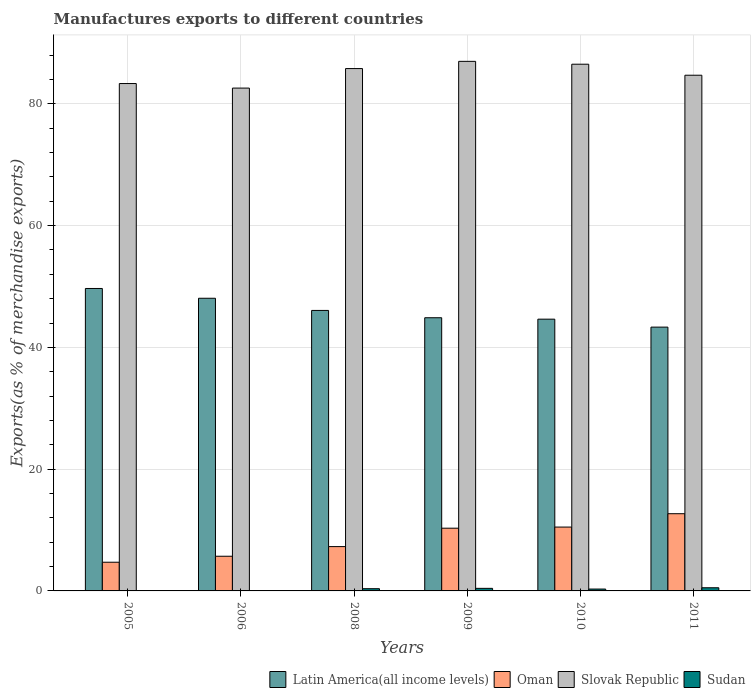How many bars are there on the 1st tick from the right?
Your answer should be compact. 4. What is the label of the 6th group of bars from the left?
Make the answer very short. 2011. In how many cases, is the number of bars for a given year not equal to the number of legend labels?
Keep it short and to the point. 0. What is the percentage of exports to different countries in Latin America(all income levels) in 2005?
Provide a succinct answer. 49.68. Across all years, what is the maximum percentage of exports to different countries in Latin America(all income levels)?
Provide a succinct answer. 49.68. Across all years, what is the minimum percentage of exports to different countries in Slovak Republic?
Provide a short and direct response. 82.59. In which year was the percentage of exports to different countries in Sudan minimum?
Offer a very short reply. 2006. What is the total percentage of exports to different countries in Oman in the graph?
Make the answer very short. 51.16. What is the difference between the percentage of exports to different countries in Oman in 2005 and that in 2008?
Your answer should be compact. -2.57. What is the difference between the percentage of exports to different countries in Latin America(all income levels) in 2005 and the percentage of exports to different countries in Slovak Republic in 2006?
Ensure brevity in your answer.  -32.92. What is the average percentage of exports to different countries in Sudan per year?
Give a very brief answer. 0.28. In the year 2011, what is the difference between the percentage of exports to different countries in Latin America(all income levels) and percentage of exports to different countries in Oman?
Provide a succinct answer. 30.65. What is the ratio of the percentage of exports to different countries in Slovak Republic in 2010 to that in 2011?
Provide a short and direct response. 1.02. Is the percentage of exports to different countries in Sudan in 2005 less than that in 2010?
Ensure brevity in your answer.  Yes. Is the difference between the percentage of exports to different countries in Latin America(all income levels) in 2008 and 2009 greater than the difference between the percentage of exports to different countries in Oman in 2008 and 2009?
Your answer should be very brief. Yes. What is the difference between the highest and the second highest percentage of exports to different countries in Latin America(all income levels)?
Offer a terse response. 1.6. What is the difference between the highest and the lowest percentage of exports to different countries in Latin America(all income levels)?
Provide a succinct answer. 6.35. In how many years, is the percentage of exports to different countries in Oman greater than the average percentage of exports to different countries in Oman taken over all years?
Your response must be concise. 3. What does the 4th bar from the left in 2011 represents?
Give a very brief answer. Sudan. What does the 4th bar from the right in 2009 represents?
Ensure brevity in your answer.  Latin America(all income levels). Is it the case that in every year, the sum of the percentage of exports to different countries in Oman and percentage of exports to different countries in Latin America(all income levels) is greater than the percentage of exports to different countries in Slovak Republic?
Give a very brief answer. No. How many bars are there?
Your response must be concise. 24. Are all the bars in the graph horizontal?
Provide a succinct answer. No. How many years are there in the graph?
Provide a short and direct response. 6. What is the difference between two consecutive major ticks on the Y-axis?
Your answer should be compact. 20. Does the graph contain grids?
Make the answer very short. Yes. Where does the legend appear in the graph?
Offer a terse response. Bottom right. How many legend labels are there?
Ensure brevity in your answer.  4. What is the title of the graph?
Offer a very short reply. Manufactures exports to different countries. What is the label or title of the Y-axis?
Offer a very short reply. Exports(as % of merchandise exports). What is the Exports(as % of merchandise exports) of Latin America(all income levels) in 2005?
Provide a succinct answer. 49.68. What is the Exports(as % of merchandise exports) in Oman in 2005?
Provide a succinct answer. 4.71. What is the Exports(as % of merchandise exports) in Slovak Republic in 2005?
Your answer should be compact. 83.34. What is the Exports(as % of merchandise exports) of Sudan in 2005?
Provide a short and direct response. 0.06. What is the Exports(as % of merchandise exports) in Latin America(all income levels) in 2006?
Keep it short and to the point. 48.07. What is the Exports(as % of merchandise exports) in Oman in 2006?
Provide a succinct answer. 5.7. What is the Exports(as % of merchandise exports) in Slovak Republic in 2006?
Your answer should be compact. 82.59. What is the Exports(as % of merchandise exports) of Sudan in 2006?
Provide a succinct answer. 0.03. What is the Exports(as % of merchandise exports) in Latin America(all income levels) in 2008?
Provide a succinct answer. 46.07. What is the Exports(as % of merchandise exports) in Oman in 2008?
Provide a short and direct response. 7.28. What is the Exports(as % of merchandise exports) of Slovak Republic in 2008?
Ensure brevity in your answer.  85.79. What is the Exports(as % of merchandise exports) of Sudan in 2008?
Offer a terse response. 0.36. What is the Exports(as % of merchandise exports) of Latin America(all income levels) in 2009?
Your answer should be very brief. 44.87. What is the Exports(as % of merchandise exports) of Oman in 2009?
Your answer should be compact. 10.3. What is the Exports(as % of merchandise exports) in Slovak Republic in 2009?
Your answer should be very brief. 86.98. What is the Exports(as % of merchandise exports) of Sudan in 2009?
Your answer should be very brief. 0.42. What is the Exports(as % of merchandise exports) of Latin America(all income levels) in 2010?
Make the answer very short. 44.64. What is the Exports(as % of merchandise exports) of Oman in 2010?
Keep it short and to the point. 10.49. What is the Exports(as % of merchandise exports) in Slovak Republic in 2010?
Offer a very short reply. 86.51. What is the Exports(as % of merchandise exports) in Sudan in 2010?
Provide a short and direct response. 0.31. What is the Exports(as % of merchandise exports) of Latin America(all income levels) in 2011?
Make the answer very short. 43.33. What is the Exports(as % of merchandise exports) in Oman in 2011?
Offer a very short reply. 12.68. What is the Exports(as % of merchandise exports) of Slovak Republic in 2011?
Ensure brevity in your answer.  84.7. What is the Exports(as % of merchandise exports) of Sudan in 2011?
Provide a short and direct response. 0.52. Across all years, what is the maximum Exports(as % of merchandise exports) in Latin America(all income levels)?
Offer a terse response. 49.68. Across all years, what is the maximum Exports(as % of merchandise exports) in Oman?
Make the answer very short. 12.68. Across all years, what is the maximum Exports(as % of merchandise exports) of Slovak Republic?
Offer a terse response. 86.98. Across all years, what is the maximum Exports(as % of merchandise exports) of Sudan?
Your answer should be compact. 0.52. Across all years, what is the minimum Exports(as % of merchandise exports) of Latin America(all income levels)?
Provide a short and direct response. 43.33. Across all years, what is the minimum Exports(as % of merchandise exports) of Oman?
Give a very brief answer. 4.71. Across all years, what is the minimum Exports(as % of merchandise exports) of Slovak Republic?
Offer a terse response. 82.59. Across all years, what is the minimum Exports(as % of merchandise exports) in Sudan?
Make the answer very short. 0.03. What is the total Exports(as % of merchandise exports) in Latin America(all income levels) in the graph?
Make the answer very short. 276.65. What is the total Exports(as % of merchandise exports) of Oman in the graph?
Provide a short and direct response. 51.16. What is the total Exports(as % of merchandise exports) of Slovak Republic in the graph?
Your answer should be compact. 509.92. What is the total Exports(as % of merchandise exports) of Sudan in the graph?
Keep it short and to the point. 1.7. What is the difference between the Exports(as % of merchandise exports) of Latin America(all income levels) in 2005 and that in 2006?
Keep it short and to the point. 1.6. What is the difference between the Exports(as % of merchandise exports) in Oman in 2005 and that in 2006?
Provide a succinct answer. -0.98. What is the difference between the Exports(as % of merchandise exports) of Slovak Republic in 2005 and that in 2006?
Ensure brevity in your answer.  0.75. What is the difference between the Exports(as % of merchandise exports) of Sudan in 2005 and that in 2006?
Your answer should be very brief. 0.03. What is the difference between the Exports(as % of merchandise exports) in Latin America(all income levels) in 2005 and that in 2008?
Your answer should be very brief. 3.6. What is the difference between the Exports(as % of merchandise exports) of Oman in 2005 and that in 2008?
Make the answer very short. -2.57. What is the difference between the Exports(as % of merchandise exports) in Slovak Republic in 2005 and that in 2008?
Provide a succinct answer. -2.46. What is the difference between the Exports(as % of merchandise exports) of Sudan in 2005 and that in 2008?
Provide a short and direct response. -0.31. What is the difference between the Exports(as % of merchandise exports) in Latin America(all income levels) in 2005 and that in 2009?
Make the answer very short. 4.8. What is the difference between the Exports(as % of merchandise exports) in Oman in 2005 and that in 2009?
Your answer should be compact. -5.59. What is the difference between the Exports(as % of merchandise exports) of Slovak Republic in 2005 and that in 2009?
Give a very brief answer. -3.64. What is the difference between the Exports(as % of merchandise exports) of Sudan in 2005 and that in 2009?
Your answer should be very brief. -0.36. What is the difference between the Exports(as % of merchandise exports) in Latin America(all income levels) in 2005 and that in 2010?
Give a very brief answer. 5.04. What is the difference between the Exports(as % of merchandise exports) of Oman in 2005 and that in 2010?
Offer a very short reply. -5.77. What is the difference between the Exports(as % of merchandise exports) in Slovak Republic in 2005 and that in 2010?
Your answer should be compact. -3.17. What is the difference between the Exports(as % of merchandise exports) in Sudan in 2005 and that in 2010?
Offer a very short reply. -0.25. What is the difference between the Exports(as % of merchandise exports) in Latin America(all income levels) in 2005 and that in 2011?
Ensure brevity in your answer.  6.35. What is the difference between the Exports(as % of merchandise exports) in Oman in 2005 and that in 2011?
Your answer should be compact. -7.97. What is the difference between the Exports(as % of merchandise exports) of Slovak Republic in 2005 and that in 2011?
Your answer should be very brief. -1.37. What is the difference between the Exports(as % of merchandise exports) of Sudan in 2005 and that in 2011?
Offer a terse response. -0.46. What is the difference between the Exports(as % of merchandise exports) in Latin America(all income levels) in 2006 and that in 2008?
Your response must be concise. 2. What is the difference between the Exports(as % of merchandise exports) of Oman in 2006 and that in 2008?
Provide a short and direct response. -1.58. What is the difference between the Exports(as % of merchandise exports) of Slovak Republic in 2006 and that in 2008?
Ensure brevity in your answer.  -3.2. What is the difference between the Exports(as % of merchandise exports) in Sudan in 2006 and that in 2008?
Your answer should be very brief. -0.34. What is the difference between the Exports(as % of merchandise exports) of Latin America(all income levels) in 2006 and that in 2009?
Offer a very short reply. 3.2. What is the difference between the Exports(as % of merchandise exports) in Oman in 2006 and that in 2009?
Offer a very short reply. -4.61. What is the difference between the Exports(as % of merchandise exports) of Slovak Republic in 2006 and that in 2009?
Provide a succinct answer. -4.39. What is the difference between the Exports(as % of merchandise exports) of Sudan in 2006 and that in 2009?
Your response must be concise. -0.39. What is the difference between the Exports(as % of merchandise exports) of Latin America(all income levels) in 2006 and that in 2010?
Your answer should be compact. 3.44. What is the difference between the Exports(as % of merchandise exports) of Oman in 2006 and that in 2010?
Offer a very short reply. -4.79. What is the difference between the Exports(as % of merchandise exports) of Slovak Republic in 2006 and that in 2010?
Offer a very short reply. -3.92. What is the difference between the Exports(as % of merchandise exports) of Sudan in 2006 and that in 2010?
Provide a succinct answer. -0.28. What is the difference between the Exports(as % of merchandise exports) of Latin America(all income levels) in 2006 and that in 2011?
Ensure brevity in your answer.  4.74. What is the difference between the Exports(as % of merchandise exports) of Oman in 2006 and that in 2011?
Your response must be concise. -6.98. What is the difference between the Exports(as % of merchandise exports) in Slovak Republic in 2006 and that in 2011?
Offer a terse response. -2.11. What is the difference between the Exports(as % of merchandise exports) in Sudan in 2006 and that in 2011?
Offer a very short reply. -0.49. What is the difference between the Exports(as % of merchandise exports) of Latin America(all income levels) in 2008 and that in 2009?
Ensure brevity in your answer.  1.2. What is the difference between the Exports(as % of merchandise exports) of Oman in 2008 and that in 2009?
Provide a succinct answer. -3.02. What is the difference between the Exports(as % of merchandise exports) of Slovak Republic in 2008 and that in 2009?
Your answer should be compact. -1.19. What is the difference between the Exports(as % of merchandise exports) in Sudan in 2008 and that in 2009?
Your response must be concise. -0.06. What is the difference between the Exports(as % of merchandise exports) of Latin America(all income levels) in 2008 and that in 2010?
Give a very brief answer. 1.44. What is the difference between the Exports(as % of merchandise exports) in Oman in 2008 and that in 2010?
Provide a short and direct response. -3.21. What is the difference between the Exports(as % of merchandise exports) of Slovak Republic in 2008 and that in 2010?
Offer a terse response. -0.72. What is the difference between the Exports(as % of merchandise exports) of Sudan in 2008 and that in 2010?
Ensure brevity in your answer.  0.06. What is the difference between the Exports(as % of merchandise exports) of Latin America(all income levels) in 2008 and that in 2011?
Make the answer very short. 2.74. What is the difference between the Exports(as % of merchandise exports) in Oman in 2008 and that in 2011?
Your answer should be compact. -5.4. What is the difference between the Exports(as % of merchandise exports) of Slovak Republic in 2008 and that in 2011?
Make the answer very short. 1.09. What is the difference between the Exports(as % of merchandise exports) in Sudan in 2008 and that in 2011?
Provide a short and direct response. -0.15. What is the difference between the Exports(as % of merchandise exports) of Latin America(all income levels) in 2009 and that in 2010?
Offer a very short reply. 0.23. What is the difference between the Exports(as % of merchandise exports) in Oman in 2009 and that in 2010?
Make the answer very short. -0.18. What is the difference between the Exports(as % of merchandise exports) in Slovak Republic in 2009 and that in 2010?
Provide a short and direct response. 0.47. What is the difference between the Exports(as % of merchandise exports) of Sudan in 2009 and that in 2010?
Give a very brief answer. 0.11. What is the difference between the Exports(as % of merchandise exports) in Latin America(all income levels) in 2009 and that in 2011?
Give a very brief answer. 1.54. What is the difference between the Exports(as % of merchandise exports) of Oman in 2009 and that in 2011?
Provide a succinct answer. -2.38. What is the difference between the Exports(as % of merchandise exports) in Slovak Republic in 2009 and that in 2011?
Keep it short and to the point. 2.28. What is the difference between the Exports(as % of merchandise exports) in Sudan in 2009 and that in 2011?
Provide a succinct answer. -0.1. What is the difference between the Exports(as % of merchandise exports) in Latin America(all income levels) in 2010 and that in 2011?
Your response must be concise. 1.31. What is the difference between the Exports(as % of merchandise exports) of Oman in 2010 and that in 2011?
Offer a very short reply. -2.19. What is the difference between the Exports(as % of merchandise exports) in Slovak Republic in 2010 and that in 2011?
Provide a succinct answer. 1.81. What is the difference between the Exports(as % of merchandise exports) in Sudan in 2010 and that in 2011?
Make the answer very short. -0.21. What is the difference between the Exports(as % of merchandise exports) in Latin America(all income levels) in 2005 and the Exports(as % of merchandise exports) in Oman in 2006?
Provide a succinct answer. 43.98. What is the difference between the Exports(as % of merchandise exports) in Latin America(all income levels) in 2005 and the Exports(as % of merchandise exports) in Slovak Republic in 2006?
Your response must be concise. -32.92. What is the difference between the Exports(as % of merchandise exports) in Latin America(all income levels) in 2005 and the Exports(as % of merchandise exports) in Sudan in 2006?
Make the answer very short. 49.65. What is the difference between the Exports(as % of merchandise exports) in Oman in 2005 and the Exports(as % of merchandise exports) in Slovak Republic in 2006?
Your answer should be compact. -77.88. What is the difference between the Exports(as % of merchandise exports) of Oman in 2005 and the Exports(as % of merchandise exports) of Sudan in 2006?
Your answer should be compact. 4.69. What is the difference between the Exports(as % of merchandise exports) of Slovak Republic in 2005 and the Exports(as % of merchandise exports) of Sudan in 2006?
Make the answer very short. 83.31. What is the difference between the Exports(as % of merchandise exports) of Latin America(all income levels) in 2005 and the Exports(as % of merchandise exports) of Oman in 2008?
Your answer should be very brief. 42.4. What is the difference between the Exports(as % of merchandise exports) of Latin America(all income levels) in 2005 and the Exports(as % of merchandise exports) of Slovak Republic in 2008?
Your answer should be compact. -36.12. What is the difference between the Exports(as % of merchandise exports) in Latin America(all income levels) in 2005 and the Exports(as % of merchandise exports) in Sudan in 2008?
Give a very brief answer. 49.31. What is the difference between the Exports(as % of merchandise exports) in Oman in 2005 and the Exports(as % of merchandise exports) in Slovak Republic in 2008?
Provide a short and direct response. -81.08. What is the difference between the Exports(as % of merchandise exports) of Oman in 2005 and the Exports(as % of merchandise exports) of Sudan in 2008?
Offer a terse response. 4.35. What is the difference between the Exports(as % of merchandise exports) in Slovak Republic in 2005 and the Exports(as % of merchandise exports) in Sudan in 2008?
Your answer should be compact. 82.97. What is the difference between the Exports(as % of merchandise exports) of Latin America(all income levels) in 2005 and the Exports(as % of merchandise exports) of Oman in 2009?
Provide a succinct answer. 39.37. What is the difference between the Exports(as % of merchandise exports) in Latin America(all income levels) in 2005 and the Exports(as % of merchandise exports) in Slovak Republic in 2009?
Offer a terse response. -37.31. What is the difference between the Exports(as % of merchandise exports) of Latin America(all income levels) in 2005 and the Exports(as % of merchandise exports) of Sudan in 2009?
Provide a succinct answer. 49.25. What is the difference between the Exports(as % of merchandise exports) in Oman in 2005 and the Exports(as % of merchandise exports) in Slovak Republic in 2009?
Provide a short and direct response. -82.27. What is the difference between the Exports(as % of merchandise exports) in Oman in 2005 and the Exports(as % of merchandise exports) in Sudan in 2009?
Offer a very short reply. 4.29. What is the difference between the Exports(as % of merchandise exports) of Slovak Republic in 2005 and the Exports(as % of merchandise exports) of Sudan in 2009?
Make the answer very short. 82.91. What is the difference between the Exports(as % of merchandise exports) of Latin America(all income levels) in 2005 and the Exports(as % of merchandise exports) of Oman in 2010?
Ensure brevity in your answer.  39.19. What is the difference between the Exports(as % of merchandise exports) of Latin America(all income levels) in 2005 and the Exports(as % of merchandise exports) of Slovak Republic in 2010?
Ensure brevity in your answer.  -36.84. What is the difference between the Exports(as % of merchandise exports) of Latin America(all income levels) in 2005 and the Exports(as % of merchandise exports) of Sudan in 2010?
Give a very brief answer. 49.37. What is the difference between the Exports(as % of merchandise exports) of Oman in 2005 and the Exports(as % of merchandise exports) of Slovak Republic in 2010?
Provide a short and direct response. -81.8. What is the difference between the Exports(as % of merchandise exports) in Oman in 2005 and the Exports(as % of merchandise exports) in Sudan in 2010?
Offer a very short reply. 4.41. What is the difference between the Exports(as % of merchandise exports) of Slovak Republic in 2005 and the Exports(as % of merchandise exports) of Sudan in 2010?
Provide a succinct answer. 83.03. What is the difference between the Exports(as % of merchandise exports) in Latin America(all income levels) in 2005 and the Exports(as % of merchandise exports) in Oman in 2011?
Your answer should be very brief. 36.99. What is the difference between the Exports(as % of merchandise exports) of Latin America(all income levels) in 2005 and the Exports(as % of merchandise exports) of Slovak Republic in 2011?
Give a very brief answer. -35.03. What is the difference between the Exports(as % of merchandise exports) in Latin America(all income levels) in 2005 and the Exports(as % of merchandise exports) in Sudan in 2011?
Ensure brevity in your answer.  49.16. What is the difference between the Exports(as % of merchandise exports) in Oman in 2005 and the Exports(as % of merchandise exports) in Slovak Republic in 2011?
Provide a succinct answer. -79.99. What is the difference between the Exports(as % of merchandise exports) in Oman in 2005 and the Exports(as % of merchandise exports) in Sudan in 2011?
Give a very brief answer. 4.19. What is the difference between the Exports(as % of merchandise exports) in Slovak Republic in 2005 and the Exports(as % of merchandise exports) in Sudan in 2011?
Ensure brevity in your answer.  82.82. What is the difference between the Exports(as % of merchandise exports) of Latin America(all income levels) in 2006 and the Exports(as % of merchandise exports) of Oman in 2008?
Offer a terse response. 40.79. What is the difference between the Exports(as % of merchandise exports) of Latin America(all income levels) in 2006 and the Exports(as % of merchandise exports) of Slovak Republic in 2008?
Ensure brevity in your answer.  -37.72. What is the difference between the Exports(as % of merchandise exports) in Latin America(all income levels) in 2006 and the Exports(as % of merchandise exports) in Sudan in 2008?
Provide a short and direct response. 47.71. What is the difference between the Exports(as % of merchandise exports) in Oman in 2006 and the Exports(as % of merchandise exports) in Slovak Republic in 2008?
Offer a terse response. -80.1. What is the difference between the Exports(as % of merchandise exports) in Oman in 2006 and the Exports(as % of merchandise exports) in Sudan in 2008?
Offer a terse response. 5.33. What is the difference between the Exports(as % of merchandise exports) in Slovak Republic in 2006 and the Exports(as % of merchandise exports) in Sudan in 2008?
Ensure brevity in your answer.  82.23. What is the difference between the Exports(as % of merchandise exports) in Latin America(all income levels) in 2006 and the Exports(as % of merchandise exports) in Oman in 2009?
Make the answer very short. 37.77. What is the difference between the Exports(as % of merchandise exports) in Latin America(all income levels) in 2006 and the Exports(as % of merchandise exports) in Slovak Republic in 2009?
Provide a short and direct response. -38.91. What is the difference between the Exports(as % of merchandise exports) in Latin America(all income levels) in 2006 and the Exports(as % of merchandise exports) in Sudan in 2009?
Keep it short and to the point. 47.65. What is the difference between the Exports(as % of merchandise exports) in Oman in 2006 and the Exports(as % of merchandise exports) in Slovak Republic in 2009?
Your response must be concise. -81.28. What is the difference between the Exports(as % of merchandise exports) of Oman in 2006 and the Exports(as % of merchandise exports) of Sudan in 2009?
Provide a succinct answer. 5.27. What is the difference between the Exports(as % of merchandise exports) in Slovak Republic in 2006 and the Exports(as % of merchandise exports) in Sudan in 2009?
Keep it short and to the point. 82.17. What is the difference between the Exports(as % of merchandise exports) in Latin America(all income levels) in 2006 and the Exports(as % of merchandise exports) in Oman in 2010?
Offer a very short reply. 37.58. What is the difference between the Exports(as % of merchandise exports) of Latin America(all income levels) in 2006 and the Exports(as % of merchandise exports) of Slovak Republic in 2010?
Keep it short and to the point. -38.44. What is the difference between the Exports(as % of merchandise exports) of Latin America(all income levels) in 2006 and the Exports(as % of merchandise exports) of Sudan in 2010?
Offer a very short reply. 47.76. What is the difference between the Exports(as % of merchandise exports) of Oman in 2006 and the Exports(as % of merchandise exports) of Slovak Republic in 2010?
Offer a terse response. -80.81. What is the difference between the Exports(as % of merchandise exports) in Oman in 2006 and the Exports(as % of merchandise exports) in Sudan in 2010?
Ensure brevity in your answer.  5.39. What is the difference between the Exports(as % of merchandise exports) of Slovak Republic in 2006 and the Exports(as % of merchandise exports) of Sudan in 2010?
Your answer should be very brief. 82.28. What is the difference between the Exports(as % of merchandise exports) in Latin America(all income levels) in 2006 and the Exports(as % of merchandise exports) in Oman in 2011?
Your answer should be very brief. 35.39. What is the difference between the Exports(as % of merchandise exports) of Latin America(all income levels) in 2006 and the Exports(as % of merchandise exports) of Slovak Republic in 2011?
Ensure brevity in your answer.  -36.63. What is the difference between the Exports(as % of merchandise exports) in Latin America(all income levels) in 2006 and the Exports(as % of merchandise exports) in Sudan in 2011?
Make the answer very short. 47.55. What is the difference between the Exports(as % of merchandise exports) in Oman in 2006 and the Exports(as % of merchandise exports) in Slovak Republic in 2011?
Offer a very short reply. -79.01. What is the difference between the Exports(as % of merchandise exports) in Oman in 2006 and the Exports(as % of merchandise exports) in Sudan in 2011?
Provide a succinct answer. 5.18. What is the difference between the Exports(as % of merchandise exports) in Slovak Republic in 2006 and the Exports(as % of merchandise exports) in Sudan in 2011?
Provide a succinct answer. 82.07. What is the difference between the Exports(as % of merchandise exports) of Latin America(all income levels) in 2008 and the Exports(as % of merchandise exports) of Oman in 2009?
Provide a short and direct response. 35.77. What is the difference between the Exports(as % of merchandise exports) in Latin America(all income levels) in 2008 and the Exports(as % of merchandise exports) in Slovak Republic in 2009?
Your response must be concise. -40.91. What is the difference between the Exports(as % of merchandise exports) of Latin America(all income levels) in 2008 and the Exports(as % of merchandise exports) of Sudan in 2009?
Provide a short and direct response. 45.65. What is the difference between the Exports(as % of merchandise exports) in Oman in 2008 and the Exports(as % of merchandise exports) in Slovak Republic in 2009?
Ensure brevity in your answer.  -79.7. What is the difference between the Exports(as % of merchandise exports) of Oman in 2008 and the Exports(as % of merchandise exports) of Sudan in 2009?
Keep it short and to the point. 6.86. What is the difference between the Exports(as % of merchandise exports) in Slovak Republic in 2008 and the Exports(as % of merchandise exports) in Sudan in 2009?
Your response must be concise. 85.37. What is the difference between the Exports(as % of merchandise exports) of Latin America(all income levels) in 2008 and the Exports(as % of merchandise exports) of Oman in 2010?
Offer a terse response. 35.58. What is the difference between the Exports(as % of merchandise exports) in Latin America(all income levels) in 2008 and the Exports(as % of merchandise exports) in Slovak Republic in 2010?
Give a very brief answer. -40.44. What is the difference between the Exports(as % of merchandise exports) in Latin America(all income levels) in 2008 and the Exports(as % of merchandise exports) in Sudan in 2010?
Offer a very short reply. 45.76. What is the difference between the Exports(as % of merchandise exports) in Oman in 2008 and the Exports(as % of merchandise exports) in Slovak Republic in 2010?
Give a very brief answer. -79.23. What is the difference between the Exports(as % of merchandise exports) of Oman in 2008 and the Exports(as % of merchandise exports) of Sudan in 2010?
Provide a succinct answer. 6.97. What is the difference between the Exports(as % of merchandise exports) in Slovak Republic in 2008 and the Exports(as % of merchandise exports) in Sudan in 2010?
Offer a very short reply. 85.49. What is the difference between the Exports(as % of merchandise exports) of Latin America(all income levels) in 2008 and the Exports(as % of merchandise exports) of Oman in 2011?
Give a very brief answer. 33.39. What is the difference between the Exports(as % of merchandise exports) in Latin America(all income levels) in 2008 and the Exports(as % of merchandise exports) in Slovak Republic in 2011?
Make the answer very short. -38.63. What is the difference between the Exports(as % of merchandise exports) of Latin America(all income levels) in 2008 and the Exports(as % of merchandise exports) of Sudan in 2011?
Make the answer very short. 45.55. What is the difference between the Exports(as % of merchandise exports) in Oman in 2008 and the Exports(as % of merchandise exports) in Slovak Republic in 2011?
Offer a very short reply. -77.42. What is the difference between the Exports(as % of merchandise exports) in Oman in 2008 and the Exports(as % of merchandise exports) in Sudan in 2011?
Keep it short and to the point. 6.76. What is the difference between the Exports(as % of merchandise exports) in Slovak Republic in 2008 and the Exports(as % of merchandise exports) in Sudan in 2011?
Offer a terse response. 85.28. What is the difference between the Exports(as % of merchandise exports) in Latin America(all income levels) in 2009 and the Exports(as % of merchandise exports) in Oman in 2010?
Ensure brevity in your answer.  34.38. What is the difference between the Exports(as % of merchandise exports) of Latin America(all income levels) in 2009 and the Exports(as % of merchandise exports) of Slovak Republic in 2010?
Your answer should be very brief. -41.64. What is the difference between the Exports(as % of merchandise exports) in Latin America(all income levels) in 2009 and the Exports(as % of merchandise exports) in Sudan in 2010?
Ensure brevity in your answer.  44.56. What is the difference between the Exports(as % of merchandise exports) in Oman in 2009 and the Exports(as % of merchandise exports) in Slovak Republic in 2010?
Ensure brevity in your answer.  -76.21. What is the difference between the Exports(as % of merchandise exports) in Oman in 2009 and the Exports(as % of merchandise exports) in Sudan in 2010?
Offer a terse response. 10. What is the difference between the Exports(as % of merchandise exports) in Slovak Republic in 2009 and the Exports(as % of merchandise exports) in Sudan in 2010?
Provide a succinct answer. 86.67. What is the difference between the Exports(as % of merchandise exports) of Latin America(all income levels) in 2009 and the Exports(as % of merchandise exports) of Oman in 2011?
Provide a succinct answer. 32.19. What is the difference between the Exports(as % of merchandise exports) of Latin America(all income levels) in 2009 and the Exports(as % of merchandise exports) of Slovak Republic in 2011?
Offer a very short reply. -39.83. What is the difference between the Exports(as % of merchandise exports) of Latin America(all income levels) in 2009 and the Exports(as % of merchandise exports) of Sudan in 2011?
Give a very brief answer. 44.35. What is the difference between the Exports(as % of merchandise exports) in Oman in 2009 and the Exports(as % of merchandise exports) in Slovak Republic in 2011?
Ensure brevity in your answer.  -74.4. What is the difference between the Exports(as % of merchandise exports) in Oman in 2009 and the Exports(as % of merchandise exports) in Sudan in 2011?
Your answer should be compact. 9.78. What is the difference between the Exports(as % of merchandise exports) of Slovak Republic in 2009 and the Exports(as % of merchandise exports) of Sudan in 2011?
Your answer should be very brief. 86.46. What is the difference between the Exports(as % of merchandise exports) in Latin America(all income levels) in 2010 and the Exports(as % of merchandise exports) in Oman in 2011?
Provide a short and direct response. 31.95. What is the difference between the Exports(as % of merchandise exports) in Latin America(all income levels) in 2010 and the Exports(as % of merchandise exports) in Slovak Republic in 2011?
Offer a terse response. -40.07. What is the difference between the Exports(as % of merchandise exports) in Latin America(all income levels) in 2010 and the Exports(as % of merchandise exports) in Sudan in 2011?
Provide a short and direct response. 44.12. What is the difference between the Exports(as % of merchandise exports) in Oman in 2010 and the Exports(as % of merchandise exports) in Slovak Republic in 2011?
Your response must be concise. -74.22. What is the difference between the Exports(as % of merchandise exports) in Oman in 2010 and the Exports(as % of merchandise exports) in Sudan in 2011?
Give a very brief answer. 9.97. What is the difference between the Exports(as % of merchandise exports) in Slovak Republic in 2010 and the Exports(as % of merchandise exports) in Sudan in 2011?
Your answer should be compact. 85.99. What is the average Exports(as % of merchandise exports) of Latin America(all income levels) per year?
Keep it short and to the point. 46.11. What is the average Exports(as % of merchandise exports) of Oman per year?
Your answer should be very brief. 8.53. What is the average Exports(as % of merchandise exports) of Slovak Republic per year?
Ensure brevity in your answer.  84.99. What is the average Exports(as % of merchandise exports) in Sudan per year?
Your response must be concise. 0.28. In the year 2005, what is the difference between the Exports(as % of merchandise exports) of Latin America(all income levels) and Exports(as % of merchandise exports) of Oman?
Your answer should be compact. 44.96. In the year 2005, what is the difference between the Exports(as % of merchandise exports) in Latin America(all income levels) and Exports(as % of merchandise exports) in Slovak Republic?
Your response must be concise. -33.66. In the year 2005, what is the difference between the Exports(as % of merchandise exports) in Latin America(all income levels) and Exports(as % of merchandise exports) in Sudan?
Provide a short and direct response. 49.62. In the year 2005, what is the difference between the Exports(as % of merchandise exports) in Oman and Exports(as % of merchandise exports) in Slovak Republic?
Make the answer very short. -78.62. In the year 2005, what is the difference between the Exports(as % of merchandise exports) in Oman and Exports(as % of merchandise exports) in Sudan?
Offer a terse response. 4.66. In the year 2005, what is the difference between the Exports(as % of merchandise exports) of Slovak Republic and Exports(as % of merchandise exports) of Sudan?
Your answer should be compact. 83.28. In the year 2006, what is the difference between the Exports(as % of merchandise exports) in Latin America(all income levels) and Exports(as % of merchandise exports) in Oman?
Keep it short and to the point. 42.37. In the year 2006, what is the difference between the Exports(as % of merchandise exports) in Latin America(all income levels) and Exports(as % of merchandise exports) in Slovak Republic?
Keep it short and to the point. -34.52. In the year 2006, what is the difference between the Exports(as % of merchandise exports) of Latin America(all income levels) and Exports(as % of merchandise exports) of Sudan?
Your response must be concise. 48.04. In the year 2006, what is the difference between the Exports(as % of merchandise exports) of Oman and Exports(as % of merchandise exports) of Slovak Republic?
Make the answer very short. -76.89. In the year 2006, what is the difference between the Exports(as % of merchandise exports) of Oman and Exports(as % of merchandise exports) of Sudan?
Ensure brevity in your answer.  5.67. In the year 2006, what is the difference between the Exports(as % of merchandise exports) of Slovak Republic and Exports(as % of merchandise exports) of Sudan?
Make the answer very short. 82.56. In the year 2008, what is the difference between the Exports(as % of merchandise exports) of Latin America(all income levels) and Exports(as % of merchandise exports) of Oman?
Your answer should be very brief. 38.79. In the year 2008, what is the difference between the Exports(as % of merchandise exports) in Latin America(all income levels) and Exports(as % of merchandise exports) in Slovak Republic?
Offer a very short reply. -39.72. In the year 2008, what is the difference between the Exports(as % of merchandise exports) of Latin America(all income levels) and Exports(as % of merchandise exports) of Sudan?
Your answer should be very brief. 45.71. In the year 2008, what is the difference between the Exports(as % of merchandise exports) in Oman and Exports(as % of merchandise exports) in Slovak Republic?
Make the answer very short. -78.51. In the year 2008, what is the difference between the Exports(as % of merchandise exports) in Oman and Exports(as % of merchandise exports) in Sudan?
Provide a short and direct response. 6.92. In the year 2008, what is the difference between the Exports(as % of merchandise exports) in Slovak Republic and Exports(as % of merchandise exports) in Sudan?
Ensure brevity in your answer.  85.43. In the year 2009, what is the difference between the Exports(as % of merchandise exports) of Latin America(all income levels) and Exports(as % of merchandise exports) of Oman?
Your answer should be compact. 34.57. In the year 2009, what is the difference between the Exports(as % of merchandise exports) in Latin America(all income levels) and Exports(as % of merchandise exports) in Slovak Republic?
Your answer should be very brief. -42.11. In the year 2009, what is the difference between the Exports(as % of merchandise exports) of Latin America(all income levels) and Exports(as % of merchandise exports) of Sudan?
Provide a short and direct response. 44.45. In the year 2009, what is the difference between the Exports(as % of merchandise exports) of Oman and Exports(as % of merchandise exports) of Slovak Republic?
Your response must be concise. -76.68. In the year 2009, what is the difference between the Exports(as % of merchandise exports) of Oman and Exports(as % of merchandise exports) of Sudan?
Offer a terse response. 9.88. In the year 2009, what is the difference between the Exports(as % of merchandise exports) of Slovak Republic and Exports(as % of merchandise exports) of Sudan?
Keep it short and to the point. 86.56. In the year 2010, what is the difference between the Exports(as % of merchandise exports) in Latin America(all income levels) and Exports(as % of merchandise exports) in Oman?
Make the answer very short. 34.15. In the year 2010, what is the difference between the Exports(as % of merchandise exports) in Latin America(all income levels) and Exports(as % of merchandise exports) in Slovak Republic?
Your answer should be very brief. -41.88. In the year 2010, what is the difference between the Exports(as % of merchandise exports) in Latin America(all income levels) and Exports(as % of merchandise exports) in Sudan?
Your answer should be very brief. 44.33. In the year 2010, what is the difference between the Exports(as % of merchandise exports) in Oman and Exports(as % of merchandise exports) in Slovak Republic?
Give a very brief answer. -76.02. In the year 2010, what is the difference between the Exports(as % of merchandise exports) of Oman and Exports(as % of merchandise exports) of Sudan?
Offer a very short reply. 10.18. In the year 2010, what is the difference between the Exports(as % of merchandise exports) in Slovak Republic and Exports(as % of merchandise exports) in Sudan?
Provide a succinct answer. 86.2. In the year 2011, what is the difference between the Exports(as % of merchandise exports) in Latin America(all income levels) and Exports(as % of merchandise exports) in Oman?
Provide a succinct answer. 30.65. In the year 2011, what is the difference between the Exports(as % of merchandise exports) in Latin America(all income levels) and Exports(as % of merchandise exports) in Slovak Republic?
Your answer should be very brief. -41.37. In the year 2011, what is the difference between the Exports(as % of merchandise exports) of Latin America(all income levels) and Exports(as % of merchandise exports) of Sudan?
Your answer should be compact. 42.81. In the year 2011, what is the difference between the Exports(as % of merchandise exports) in Oman and Exports(as % of merchandise exports) in Slovak Republic?
Provide a short and direct response. -72.02. In the year 2011, what is the difference between the Exports(as % of merchandise exports) in Oman and Exports(as % of merchandise exports) in Sudan?
Give a very brief answer. 12.16. In the year 2011, what is the difference between the Exports(as % of merchandise exports) in Slovak Republic and Exports(as % of merchandise exports) in Sudan?
Offer a very short reply. 84.18. What is the ratio of the Exports(as % of merchandise exports) in Latin America(all income levels) in 2005 to that in 2006?
Give a very brief answer. 1.03. What is the ratio of the Exports(as % of merchandise exports) in Oman in 2005 to that in 2006?
Offer a terse response. 0.83. What is the ratio of the Exports(as % of merchandise exports) of Sudan in 2005 to that in 2006?
Ensure brevity in your answer.  2.1. What is the ratio of the Exports(as % of merchandise exports) of Latin America(all income levels) in 2005 to that in 2008?
Offer a very short reply. 1.08. What is the ratio of the Exports(as % of merchandise exports) of Oman in 2005 to that in 2008?
Your response must be concise. 0.65. What is the ratio of the Exports(as % of merchandise exports) in Slovak Republic in 2005 to that in 2008?
Your response must be concise. 0.97. What is the ratio of the Exports(as % of merchandise exports) in Sudan in 2005 to that in 2008?
Your answer should be very brief. 0.16. What is the ratio of the Exports(as % of merchandise exports) in Latin America(all income levels) in 2005 to that in 2009?
Your response must be concise. 1.11. What is the ratio of the Exports(as % of merchandise exports) of Oman in 2005 to that in 2009?
Make the answer very short. 0.46. What is the ratio of the Exports(as % of merchandise exports) of Slovak Republic in 2005 to that in 2009?
Offer a very short reply. 0.96. What is the ratio of the Exports(as % of merchandise exports) of Sudan in 2005 to that in 2009?
Ensure brevity in your answer.  0.14. What is the ratio of the Exports(as % of merchandise exports) of Latin America(all income levels) in 2005 to that in 2010?
Your answer should be very brief. 1.11. What is the ratio of the Exports(as % of merchandise exports) of Oman in 2005 to that in 2010?
Keep it short and to the point. 0.45. What is the ratio of the Exports(as % of merchandise exports) in Slovak Republic in 2005 to that in 2010?
Give a very brief answer. 0.96. What is the ratio of the Exports(as % of merchandise exports) in Sudan in 2005 to that in 2010?
Provide a succinct answer. 0.19. What is the ratio of the Exports(as % of merchandise exports) of Latin America(all income levels) in 2005 to that in 2011?
Offer a very short reply. 1.15. What is the ratio of the Exports(as % of merchandise exports) in Oman in 2005 to that in 2011?
Offer a very short reply. 0.37. What is the ratio of the Exports(as % of merchandise exports) of Slovak Republic in 2005 to that in 2011?
Offer a terse response. 0.98. What is the ratio of the Exports(as % of merchandise exports) in Sudan in 2005 to that in 2011?
Ensure brevity in your answer.  0.11. What is the ratio of the Exports(as % of merchandise exports) of Latin America(all income levels) in 2006 to that in 2008?
Your answer should be very brief. 1.04. What is the ratio of the Exports(as % of merchandise exports) in Oman in 2006 to that in 2008?
Offer a terse response. 0.78. What is the ratio of the Exports(as % of merchandise exports) of Slovak Republic in 2006 to that in 2008?
Ensure brevity in your answer.  0.96. What is the ratio of the Exports(as % of merchandise exports) in Sudan in 2006 to that in 2008?
Make the answer very short. 0.08. What is the ratio of the Exports(as % of merchandise exports) of Latin America(all income levels) in 2006 to that in 2009?
Offer a terse response. 1.07. What is the ratio of the Exports(as % of merchandise exports) of Oman in 2006 to that in 2009?
Make the answer very short. 0.55. What is the ratio of the Exports(as % of merchandise exports) of Slovak Republic in 2006 to that in 2009?
Your answer should be compact. 0.95. What is the ratio of the Exports(as % of merchandise exports) of Sudan in 2006 to that in 2009?
Make the answer very short. 0.07. What is the ratio of the Exports(as % of merchandise exports) in Latin America(all income levels) in 2006 to that in 2010?
Your response must be concise. 1.08. What is the ratio of the Exports(as % of merchandise exports) in Oman in 2006 to that in 2010?
Provide a short and direct response. 0.54. What is the ratio of the Exports(as % of merchandise exports) of Slovak Republic in 2006 to that in 2010?
Provide a short and direct response. 0.95. What is the ratio of the Exports(as % of merchandise exports) in Sudan in 2006 to that in 2010?
Your answer should be very brief. 0.09. What is the ratio of the Exports(as % of merchandise exports) in Latin America(all income levels) in 2006 to that in 2011?
Your response must be concise. 1.11. What is the ratio of the Exports(as % of merchandise exports) in Oman in 2006 to that in 2011?
Your answer should be very brief. 0.45. What is the ratio of the Exports(as % of merchandise exports) of Slovak Republic in 2006 to that in 2011?
Provide a succinct answer. 0.98. What is the ratio of the Exports(as % of merchandise exports) of Sudan in 2006 to that in 2011?
Your answer should be compact. 0.05. What is the ratio of the Exports(as % of merchandise exports) of Latin America(all income levels) in 2008 to that in 2009?
Provide a short and direct response. 1.03. What is the ratio of the Exports(as % of merchandise exports) in Oman in 2008 to that in 2009?
Provide a short and direct response. 0.71. What is the ratio of the Exports(as % of merchandise exports) in Slovak Republic in 2008 to that in 2009?
Provide a succinct answer. 0.99. What is the ratio of the Exports(as % of merchandise exports) in Sudan in 2008 to that in 2009?
Make the answer very short. 0.86. What is the ratio of the Exports(as % of merchandise exports) in Latin America(all income levels) in 2008 to that in 2010?
Provide a short and direct response. 1.03. What is the ratio of the Exports(as % of merchandise exports) in Oman in 2008 to that in 2010?
Give a very brief answer. 0.69. What is the ratio of the Exports(as % of merchandise exports) in Slovak Republic in 2008 to that in 2010?
Offer a very short reply. 0.99. What is the ratio of the Exports(as % of merchandise exports) of Sudan in 2008 to that in 2010?
Your answer should be very brief. 1.19. What is the ratio of the Exports(as % of merchandise exports) of Latin America(all income levels) in 2008 to that in 2011?
Provide a succinct answer. 1.06. What is the ratio of the Exports(as % of merchandise exports) in Oman in 2008 to that in 2011?
Provide a short and direct response. 0.57. What is the ratio of the Exports(as % of merchandise exports) of Slovak Republic in 2008 to that in 2011?
Provide a succinct answer. 1.01. What is the ratio of the Exports(as % of merchandise exports) in Sudan in 2008 to that in 2011?
Offer a terse response. 0.7. What is the ratio of the Exports(as % of merchandise exports) in Oman in 2009 to that in 2010?
Your answer should be compact. 0.98. What is the ratio of the Exports(as % of merchandise exports) in Slovak Republic in 2009 to that in 2010?
Your answer should be compact. 1.01. What is the ratio of the Exports(as % of merchandise exports) in Sudan in 2009 to that in 2010?
Your response must be concise. 1.37. What is the ratio of the Exports(as % of merchandise exports) of Latin America(all income levels) in 2009 to that in 2011?
Offer a terse response. 1.04. What is the ratio of the Exports(as % of merchandise exports) in Oman in 2009 to that in 2011?
Make the answer very short. 0.81. What is the ratio of the Exports(as % of merchandise exports) in Slovak Republic in 2009 to that in 2011?
Offer a terse response. 1.03. What is the ratio of the Exports(as % of merchandise exports) of Sudan in 2009 to that in 2011?
Provide a short and direct response. 0.81. What is the ratio of the Exports(as % of merchandise exports) of Latin America(all income levels) in 2010 to that in 2011?
Keep it short and to the point. 1.03. What is the ratio of the Exports(as % of merchandise exports) in Oman in 2010 to that in 2011?
Your answer should be very brief. 0.83. What is the ratio of the Exports(as % of merchandise exports) of Slovak Republic in 2010 to that in 2011?
Provide a succinct answer. 1.02. What is the ratio of the Exports(as % of merchandise exports) in Sudan in 2010 to that in 2011?
Ensure brevity in your answer.  0.59. What is the difference between the highest and the second highest Exports(as % of merchandise exports) of Latin America(all income levels)?
Your answer should be compact. 1.6. What is the difference between the highest and the second highest Exports(as % of merchandise exports) in Oman?
Offer a very short reply. 2.19. What is the difference between the highest and the second highest Exports(as % of merchandise exports) of Slovak Republic?
Give a very brief answer. 0.47. What is the difference between the highest and the second highest Exports(as % of merchandise exports) in Sudan?
Make the answer very short. 0.1. What is the difference between the highest and the lowest Exports(as % of merchandise exports) in Latin America(all income levels)?
Ensure brevity in your answer.  6.35. What is the difference between the highest and the lowest Exports(as % of merchandise exports) in Oman?
Your response must be concise. 7.97. What is the difference between the highest and the lowest Exports(as % of merchandise exports) of Slovak Republic?
Give a very brief answer. 4.39. What is the difference between the highest and the lowest Exports(as % of merchandise exports) in Sudan?
Offer a very short reply. 0.49. 